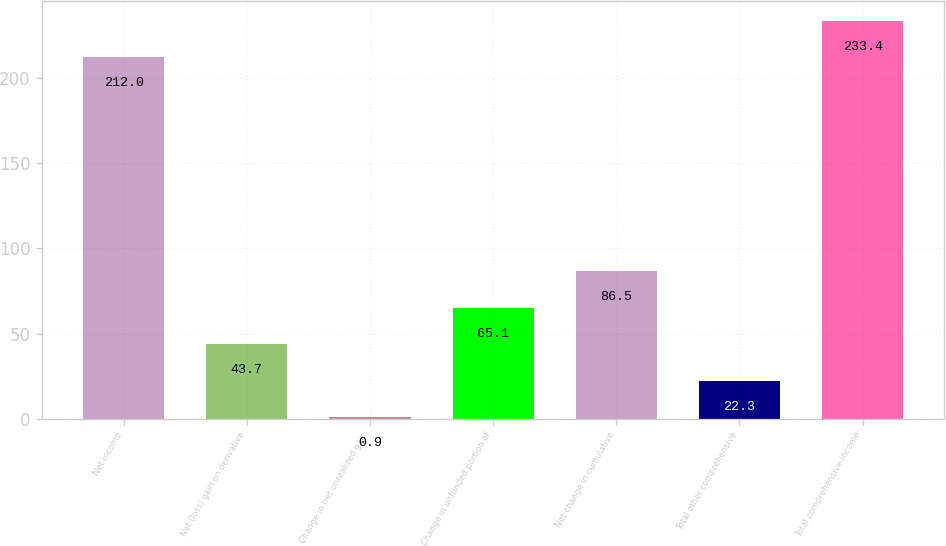Convert chart to OTSL. <chart><loc_0><loc_0><loc_500><loc_500><bar_chart><fcel>Net income<fcel>Net (loss) gain on derivative<fcel>Change in net unrealized gain<fcel>Change in unfunded portion of<fcel>Net change in cumulative<fcel>Total other comprehensive<fcel>Total comprehensive income<nl><fcel>212<fcel>43.7<fcel>0.9<fcel>65.1<fcel>86.5<fcel>22.3<fcel>233.4<nl></chart> 